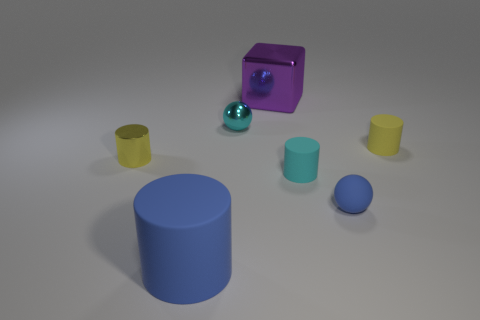Are there an equal number of tiny blue rubber things that are left of the blue matte cylinder and tiny balls in front of the cyan rubber thing?
Give a very brief answer. No. Is the shape of the tiny blue matte thing the same as the tiny cyan object behind the cyan cylinder?
Your answer should be compact. Yes. What material is the tiny ball that is the same color as the big matte thing?
Your answer should be compact. Rubber. Are there any other things that have the same shape as the big shiny object?
Offer a very short reply. No. Is the material of the big blue object the same as the small yellow object left of the cube?
Offer a very short reply. No. There is a tiny rubber cylinder left of the blue thing behind the big thing that is in front of the purple metallic cube; what color is it?
Keep it short and to the point. Cyan. Are there any other things that have the same size as the cyan cylinder?
Make the answer very short. Yes. There is a metallic ball; is it the same color as the large thing that is left of the big purple block?
Provide a short and direct response. No. The tiny metallic cylinder has what color?
Your answer should be compact. Yellow. There is a cyan object behind the cylinder right of the small matte cylinder that is in front of the yellow matte cylinder; what is its shape?
Make the answer very short. Sphere. 